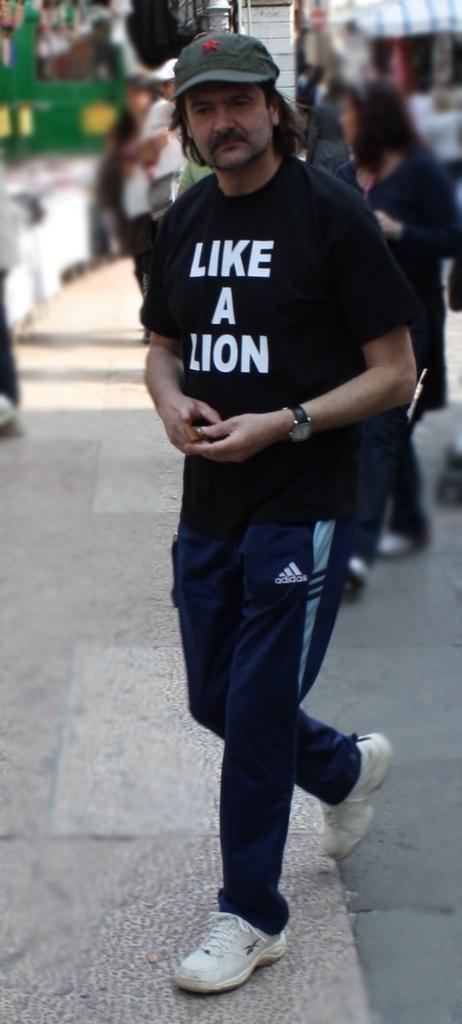In one or two sentences, can you explain what this image depicts? In the middle of this image, there is a person in black color t-shirt, walking on a footpath. In the background, there are other persons. And background is blurred. 